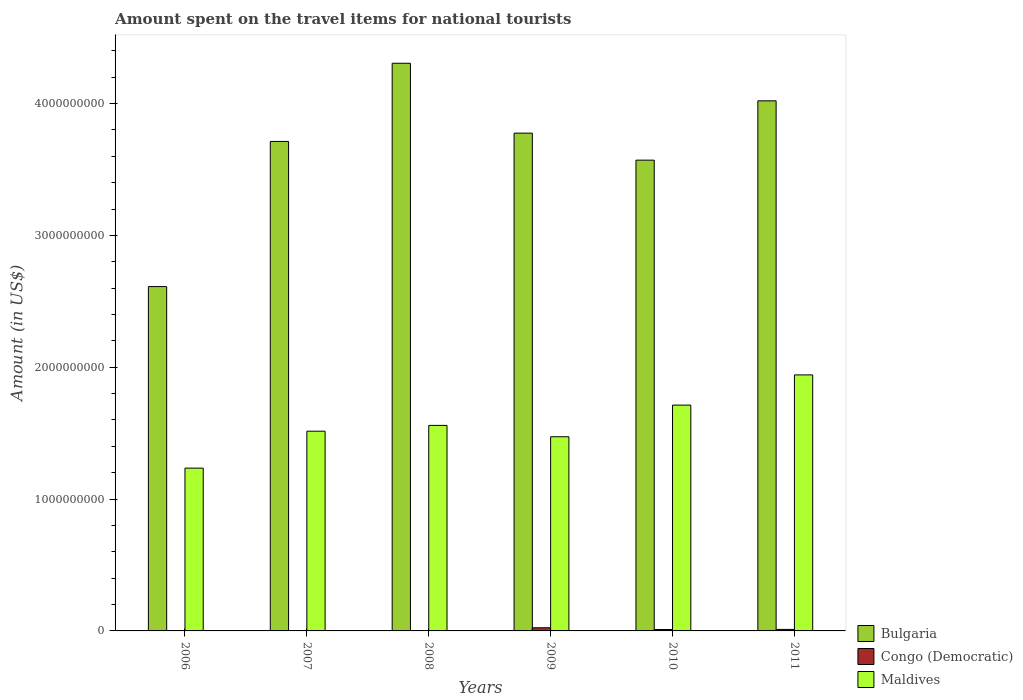How many different coloured bars are there?
Provide a succinct answer. 3. How many groups of bars are there?
Your answer should be very brief. 6. Are the number of bars per tick equal to the number of legend labels?
Make the answer very short. Yes. Are the number of bars on each tick of the X-axis equal?
Provide a succinct answer. Yes. What is the label of the 1st group of bars from the left?
Your response must be concise. 2006. What is the amount spent on the travel items for national tourists in Congo (Democratic) in 2007?
Your answer should be very brief. 7.00e+05. Across all years, what is the maximum amount spent on the travel items for national tourists in Bulgaria?
Provide a short and direct response. 4.31e+09. Across all years, what is the minimum amount spent on the travel items for national tourists in Congo (Democratic)?
Your answer should be very brief. 7.00e+05. In which year was the amount spent on the travel items for national tourists in Bulgaria minimum?
Give a very brief answer. 2006. What is the total amount spent on the travel items for national tourists in Congo (Democratic) in the graph?
Your answer should be very brief. 5.06e+07. What is the difference between the amount spent on the travel items for national tourists in Congo (Democratic) in 2010 and that in 2011?
Your response must be concise. -7.00e+05. What is the difference between the amount spent on the travel items for national tourists in Congo (Democratic) in 2008 and the amount spent on the travel items for national tourists in Bulgaria in 2009?
Offer a very short reply. -3.78e+09. What is the average amount spent on the travel items for national tourists in Maldives per year?
Ensure brevity in your answer.  1.57e+09. In the year 2008, what is the difference between the amount spent on the travel items for national tourists in Congo (Democratic) and amount spent on the travel items for national tourists in Bulgaria?
Your answer should be very brief. -4.31e+09. What is the ratio of the amount spent on the travel items for national tourists in Maldives in 2006 to that in 2007?
Ensure brevity in your answer.  0.82. Is the amount spent on the travel items for national tourists in Bulgaria in 2010 less than that in 2011?
Offer a terse response. Yes. Is the difference between the amount spent on the travel items for national tourists in Congo (Democratic) in 2007 and 2010 greater than the difference between the amount spent on the travel items for national tourists in Bulgaria in 2007 and 2010?
Make the answer very short. No. What is the difference between the highest and the second highest amount spent on the travel items for national tourists in Congo (Democratic)?
Ensure brevity in your answer.  1.26e+07. What is the difference between the highest and the lowest amount spent on the travel items for national tourists in Congo (Democratic)?
Your answer should be compact. 2.33e+07. In how many years, is the amount spent on the travel items for national tourists in Bulgaria greater than the average amount spent on the travel items for national tourists in Bulgaria taken over all years?
Your answer should be very brief. 4. What does the 2nd bar from the left in 2011 represents?
Your response must be concise. Congo (Democratic). What does the 1st bar from the right in 2009 represents?
Offer a very short reply. Maldives. How many years are there in the graph?
Provide a short and direct response. 6. What is the difference between two consecutive major ticks on the Y-axis?
Give a very brief answer. 1.00e+09. Are the values on the major ticks of Y-axis written in scientific E-notation?
Your response must be concise. No. Where does the legend appear in the graph?
Offer a very short reply. Bottom right. How are the legend labels stacked?
Provide a succinct answer. Vertical. What is the title of the graph?
Your response must be concise. Amount spent on the travel items for national tourists. What is the label or title of the X-axis?
Offer a terse response. Years. What is the Amount (in US$) in Bulgaria in 2006?
Provide a short and direct response. 2.61e+09. What is the Amount (in US$) in Congo (Democratic) in 2006?
Your response must be concise. 3.10e+06. What is the Amount (in US$) in Maldives in 2006?
Your answer should be very brief. 1.24e+09. What is the Amount (in US$) in Bulgaria in 2007?
Your response must be concise. 3.71e+09. What is the Amount (in US$) in Maldives in 2007?
Make the answer very short. 1.52e+09. What is the Amount (in US$) in Bulgaria in 2008?
Provide a succinct answer. 4.31e+09. What is the Amount (in US$) of Congo (Democratic) in 2008?
Keep it short and to the point. 7.00e+05. What is the Amount (in US$) in Maldives in 2008?
Provide a short and direct response. 1.56e+09. What is the Amount (in US$) of Bulgaria in 2009?
Give a very brief answer. 3.78e+09. What is the Amount (in US$) in Congo (Democratic) in 2009?
Keep it short and to the point. 2.40e+07. What is the Amount (in US$) of Maldives in 2009?
Provide a short and direct response. 1.47e+09. What is the Amount (in US$) of Bulgaria in 2010?
Your response must be concise. 3.57e+09. What is the Amount (in US$) of Congo (Democratic) in 2010?
Offer a terse response. 1.07e+07. What is the Amount (in US$) of Maldives in 2010?
Your response must be concise. 1.71e+09. What is the Amount (in US$) of Bulgaria in 2011?
Your response must be concise. 4.02e+09. What is the Amount (in US$) of Congo (Democratic) in 2011?
Offer a very short reply. 1.14e+07. What is the Amount (in US$) in Maldives in 2011?
Offer a terse response. 1.94e+09. Across all years, what is the maximum Amount (in US$) in Bulgaria?
Make the answer very short. 4.31e+09. Across all years, what is the maximum Amount (in US$) of Congo (Democratic)?
Offer a terse response. 2.40e+07. Across all years, what is the maximum Amount (in US$) in Maldives?
Offer a very short reply. 1.94e+09. Across all years, what is the minimum Amount (in US$) in Bulgaria?
Provide a succinct answer. 2.61e+09. Across all years, what is the minimum Amount (in US$) in Congo (Democratic)?
Provide a succinct answer. 7.00e+05. Across all years, what is the minimum Amount (in US$) of Maldives?
Your response must be concise. 1.24e+09. What is the total Amount (in US$) in Bulgaria in the graph?
Keep it short and to the point. 2.20e+1. What is the total Amount (in US$) in Congo (Democratic) in the graph?
Keep it short and to the point. 5.06e+07. What is the total Amount (in US$) in Maldives in the graph?
Offer a terse response. 9.44e+09. What is the difference between the Amount (in US$) of Bulgaria in 2006 and that in 2007?
Your response must be concise. -1.10e+09. What is the difference between the Amount (in US$) in Congo (Democratic) in 2006 and that in 2007?
Your answer should be very brief. 2.40e+06. What is the difference between the Amount (in US$) in Maldives in 2006 and that in 2007?
Offer a terse response. -2.80e+08. What is the difference between the Amount (in US$) in Bulgaria in 2006 and that in 2008?
Ensure brevity in your answer.  -1.69e+09. What is the difference between the Amount (in US$) of Congo (Democratic) in 2006 and that in 2008?
Your response must be concise. 2.40e+06. What is the difference between the Amount (in US$) of Maldives in 2006 and that in 2008?
Offer a terse response. -3.24e+08. What is the difference between the Amount (in US$) in Bulgaria in 2006 and that in 2009?
Give a very brief answer. -1.16e+09. What is the difference between the Amount (in US$) of Congo (Democratic) in 2006 and that in 2009?
Your response must be concise. -2.09e+07. What is the difference between the Amount (in US$) of Maldives in 2006 and that in 2009?
Offer a very short reply. -2.38e+08. What is the difference between the Amount (in US$) in Bulgaria in 2006 and that in 2010?
Your answer should be compact. -9.59e+08. What is the difference between the Amount (in US$) of Congo (Democratic) in 2006 and that in 2010?
Provide a short and direct response. -7.60e+06. What is the difference between the Amount (in US$) of Maldives in 2006 and that in 2010?
Your response must be concise. -4.78e+08. What is the difference between the Amount (in US$) of Bulgaria in 2006 and that in 2011?
Keep it short and to the point. -1.41e+09. What is the difference between the Amount (in US$) in Congo (Democratic) in 2006 and that in 2011?
Offer a terse response. -8.30e+06. What is the difference between the Amount (in US$) in Maldives in 2006 and that in 2011?
Your answer should be compact. -7.07e+08. What is the difference between the Amount (in US$) of Bulgaria in 2007 and that in 2008?
Your answer should be very brief. -5.93e+08. What is the difference between the Amount (in US$) of Maldives in 2007 and that in 2008?
Give a very brief answer. -4.40e+07. What is the difference between the Amount (in US$) in Bulgaria in 2007 and that in 2009?
Your answer should be very brief. -6.30e+07. What is the difference between the Amount (in US$) of Congo (Democratic) in 2007 and that in 2009?
Keep it short and to the point. -2.33e+07. What is the difference between the Amount (in US$) in Maldives in 2007 and that in 2009?
Offer a terse response. 4.20e+07. What is the difference between the Amount (in US$) in Bulgaria in 2007 and that in 2010?
Provide a succinct answer. 1.42e+08. What is the difference between the Amount (in US$) of Congo (Democratic) in 2007 and that in 2010?
Keep it short and to the point. -1.00e+07. What is the difference between the Amount (in US$) of Maldives in 2007 and that in 2010?
Your answer should be compact. -1.98e+08. What is the difference between the Amount (in US$) of Bulgaria in 2007 and that in 2011?
Offer a terse response. -3.08e+08. What is the difference between the Amount (in US$) of Congo (Democratic) in 2007 and that in 2011?
Your response must be concise. -1.07e+07. What is the difference between the Amount (in US$) of Maldives in 2007 and that in 2011?
Provide a short and direct response. -4.27e+08. What is the difference between the Amount (in US$) in Bulgaria in 2008 and that in 2009?
Your answer should be very brief. 5.30e+08. What is the difference between the Amount (in US$) in Congo (Democratic) in 2008 and that in 2009?
Ensure brevity in your answer.  -2.33e+07. What is the difference between the Amount (in US$) of Maldives in 2008 and that in 2009?
Give a very brief answer. 8.60e+07. What is the difference between the Amount (in US$) of Bulgaria in 2008 and that in 2010?
Keep it short and to the point. 7.35e+08. What is the difference between the Amount (in US$) in Congo (Democratic) in 2008 and that in 2010?
Offer a terse response. -1.00e+07. What is the difference between the Amount (in US$) of Maldives in 2008 and that in 2010?
Give a very brief answer. -1.54e+08. What is the difference between the Amount (in US$) in Bulgaria in 2008 and that in 2011?
Ensure brevity in your answer.  2.85e+08. What is the difference between the Amount (in US$) of Congo (Democratic) in 2008 and that in 2011?
Give a very brief answer. -1.07e+07. What is the difference between the Amount (in US$) in Maldives in 2008 and that in 2011?
Provide a succinct answer. -3.83e+08. What is the difference between the Amount (in US$) of Bulgaria in 2009 and that in 2010?
Ensure brevity in your answer.  2.05e+08. What is the difference between the Amount (in US$) in Congo (Democratic) in 2009 and that in 2010?
Provide a short and direct response. 1.33e+07. What is the difference between the Amount (in US$) of Maldives in 2009 and that in 2010?
Offer a very short reply. -2.40e+08. What is the difference between the Amount (in US$) in Bulgaria in 2009 and that in 2011?
Offer a very short reply. -2.45e+08. What is the difference between the Amount (in US$) of Congo (Democratic) in 2009 and that in 2011?
Provide a short and direct response. 1.26e+07. What is the difference between the Amount (in US$) in Maldives in 2009 and that in 2011?
Give a very brief answer. -4.69e+08. What is the difference between the Amount (in US$) of Bulgaria in 2010 and that in 2011?
Keep it short and to the point. -4.50e+08. What is the difference between the Amount (in US$) of Congo (Democratic) in 2010 and that in 2011?
Your answer should be very brief. -7.00e+05. What is the difference between the Amount (in US$) in Maldives in 2010 and that in 2011?
Provide a short and direct response. -2.29e+08. What is the difference between the Amount (in US$) of Bulgaria in 2006 and the Amount (in US$) of Congo (Democratic) in 2007?
Your response must be concise. 2.61e+09. What is the difference between the Amount (in US$) of Bulgaria in 2006 and the Amount (in US$) of Maldives in 2007?
Offer a very short reply. 1.10e+09. What is the difference between the Amount (in US$) in Congo (Democratic) in 2006 and the Amount (in US$) in Maldives in 2007?
Make the answer very short. -1.51e+09. What is the difference between the Amount (in US$) of Bulgaria in 2006 and the Amount (in US$) of Congo (Democratic) in 2008?
Ensure brevity in your answer.  2.61e+09. What is the difference between the Amount (in US$) of Bulgaria in 2006 and the Amount (in US$) of Maldives in 2008?
Ensure brevity in your answer.  1.05e+09. What is the difference between the Amount (in US$) of Congo (Democratic) in 2006 and the Amount (in US$) of Maldives in 2008?
Keep it short and to the point. -1.56e+09. What is the difference between the Amount (in US$) of Bulgaria in 2006 and the Amount (in US$) of Congo (Democratic) in 2009?
Offer a terse response. 2.59e+09. What is the difference between the Amount (in US$) in Bulgaria in 2006 and the Amount (in US$) in Maldives in 2009?
Your answer should be compact. 1.14e+09. What is the difference between the Amount (in US$) of Congo (Democratic) in 2006 and the Amount (in US$) of Maldives in 2009?
Offer a very short reply. -1.47e+09. What is the difference between the Amount (in US$) of Bulgaria in 2006 and the Amount (in US$) of Congo (Democratic) in 2010?
Your answer should be compact. 2.60e+09. What is the difference between the Amount (in US$) of Bulgaria in 2006 and the Amount (in US$) of Maldives in 2010?
Your answer should be compact. 8.99e+08. What is the difference between the Amount (in US$) of Congo (Democratic) in 2006 and the Amount (in US$) of Maldives in 2010?
Give a very brief answer. -1.71e+09. What is the difference between the Amount (in US$) in Bulgaria in 2006 and the Amount (in US$) in Congo (Democratic) in 2011?
Give a very brief answer. 2.60e+09. What is the difference between the Amount (in US$) in Bulgaria in 2006 and the Amount (in US$) in Maldives in 2011?
Your answer should be compact. 6.70e+08. What is the difference between the Amount (in US$) in Congo (Democratic) in 2006 and the Amount (in US$) in Maldives in 2011?
Provide a short and direct response. -1.94e+09. What is the difference between the Amount (in US$) in Bulgaria in 2007 and the Amount (in US$) in Congo (Democratic) in 2008?
Ensure brevity in your answer.  3.71e+09. What is the difference between the Amount (in US$) of Bulgaria in 2007 and the Amount (in US$) of Maldives in 2008?
Your response must be concise. 2.15e+09. What is the difference between the Amount (in US$) in Congo (Democratic) in 2007 and the Amount (in US$) in Maldives in 2008?
Give a very brief answer. -1.56e+09. What is the difference between the Amount (in US$) in Bulgaria in 2007 and the Amount (in US$) in Congo (Democratic) in 2009?
Your response must be concise. 3.69e+09. What is the difference between the Amount (in US$) of Bulgaria in 2007 and the Amount (in US$) of Maldives in 2009?
Keep it short and to the point. 2.24e+09. What is the difference between the Amount (in US$) in Congo (Democratic) in 2007 and the Amount (in US$) in Maldives in 2009?
Your response must be concise. -1.47e+09. What is the difference between the Amount (in US$) of Bulgaria in 2007 and the Amount (in US$) of Congo (Democratic) in 2010?
Offer a very short reply. 3.70e+09. What is the difference between the Amount (in US$) in Congo (Democratic) in 2007 and the Amount (in US$) in Maldives in 2010?
Make the answer very short. -1.71e+09. What is the difference between the Amount (in US$) in Bulgaria in 2007 and the Amount (in US$) in Congo (Democratic) in 2011?
Keep it short and to the point. 3.70e+09. What is the difference between the Amount (in US$) in Bulgaria in 2007 and the Amount (in US$) in Maldives in 2011?
Provide a succinct answer. 1.77e+09. What is the difference between the Amount (in US$) in Congo (Democratic) in 2007 and the Amount (in US$) in Maldives in 2011?
Your answer should be very brief. -1.94e+09. What is the difference between the Amount (in US$) in Bulgaria in 2008 and the Amount (in US$) in Congo (Democratic) in 2009?
Offer a terse response. 4.28e+09. What is the difference between the Amount (in US$) in Bulgaria in 2008 and the Amount (in US$) in Maldives in 2009?
Make the answer very short. 2.83e+09. What is the difference between the Amount (in US$) of Congo (Democratic) in 2008 and the Amount (in US$) of Maldives in 2009?
Keep it short and to the point. -1.47e+09. What is the difference between the Amount (in US$) of Bulgaria in 2008 and the Amount (in US$) of Congo (Democratic) in 2010?
Give a very brief answer. 4.30e+09. What is the difference between the Amount (in US$) in Bulgaria in 2008 and the Amount (in US$) in Maldives in 2010?
Keep it short and to the point. 2.59e+09. What is the difference between the Amount (in US$) of Congo (Democratic) in 2008 and the Amount (in US$) of Maldives in 2010?
Your response must be concise. -1.71e+09. What is the difference between the Amount (in US$) of Bulgaria in 2008 and the Amount (in US$) of Congo (Democratic) in 2011?
Keep it short and to the point. 4.29e+09. What is the difference between the Amount (in US$) in Bulgaria in 2008 and the Amount (in US$) in Maldives in 2011?
Ensure brevity in your answer.  2.36e+09. What is the difference between the Amount (in US$) of Congo (Democratic) in 2008 and the Amount (in US$) of Maldives in 2011?
Your answer should be very brief. -1.94e+09. What is the difference between the Amount (in US$) of Bulgaria in 2009 and the Amount (in US$) of Congo (Democratic) in 2010?
Provide a succinct answer. 3.77e+09. What is the difference between the Amount (in US$) of Bulgaria in 2009 and the Amount (in US$) of Maldives in 2010?
Provide a short and direct response. 2.06e+09. What is the difference between the Amount (in US$) of Congo (Democratic) in 2009 and the Amount (in US$) of Maldives in 2010?
Provide a short and direct response. -1.69e+09. What is the difference between the Amount (in US$) in Bulgaria in 2009 and the Amount (in US$) in Congo (Democratic) in 2011?
Ensure brevity in your answer.  3.76e+09. What is the difference between the Amount (in US$) of Bulgaria in 2009 and the Amount (in US$) of Maldives in 2011?
Keep it short and to the point. 1.83e+09. What is the difference between the Amount (in US$) in Congo (Democratic) in 2009 and the Amount (in US$) in Maldives in 2011?
Ensure brevity in your answer.  -1.92e+09. What is the difference between the Amount (in US$) of Bulgaria in 2010 and the Amount (in US$) of Congo (Democratic) in 2011?
Your answer should be very brief. 3.56e+09. What is the difference between the Amount (in US$) in Bulgaria in 2010 and the Amount (in US$) in Maldives in 2011?
Keep it short and to the point. 1.63e+09. What is the difference between the Amount (in US$) of Congo (Democratic) in 2010 and the Amount (in US$) of Maldives in 2011?
Keep it short and to the point. -1.93e+09. What is the average Amount (in US$) of Bulgaria per year?
Make the answer very short. 3.67e+09. What is the average Amount (in US$) in Congo (Democratic) per year?
Offer a terse response. 8.43e+06. What is the average Amount (in US$) of Maldives per year?
Your response must be concise. 1.57e+09. In the year 2006, what is the difference between the Amount (in US$) of Bulgaria and Amount (in US$) of Congo (Democratic)?
Keep it short and to the point. 2.61e+09. In the year 2006, what is the difference between the Amount (in US$) of Bulgaria and Amount (in US$) of Maldives?
Offer a very short reply. 1.38e+09. In the year 2006, what is the difference between the Amount (in US$) in Congo (Democratic) and Amount (in US$) in Maldives?
Make the answer very short. -1.23e+09. In the year 2007, what is the difference between the Amount (in US$) in Bulgaria and Amount (in US$) in Congo (Democratic)?
Provide a succinct answer. 3.71e+09. In the year 2007, what is the difference between the Amount (in US$) in Bulgaria and Amount (in US$) in Maldives?
Offer a terse response. 2.20e+09. In the year 2007, what is the difference between the Amount (in US$) in Congo (Democratic) and Amount (in US$) in Maldives?
Provide a succinct answer. -1.51e+09. In the year 2008, what is the difference between the Amount (in US$) in Bulgaria and Amount (in US$) in Congo (Democratic)?
Provide a succinct answer. 4.31e+09. In the year 2008, what is the difference between the Amount (in US$) in Bulgaria and Amount (in US$) in Maldives?
Your answer should be very brief. 2.75e+09. In the year 2008, what is the difference between the Amount (in US$) of Congo (Democratic) and Amount (in US$) of Maldives?
Your answer should be compact. -1.56e+09. In the year 2009, what is the difference between the Amount (in US$) of Bulgaria and Amount (in US$) of Congo (Democratic)?
Keep it short and to the point. 3.75e+09. In the year 2009, what is the difference between the Amount (in US$) in Bulgaria and Amount (in US$) in Maldives?
Offer a very short reply. 2.30e+09. In the year 2009, what is the difference between the Amount (in US$) in Congo (Democratic) and Amount (in US$) in Maldives?
Your answer should be very brief. -1.45e+09. In the year 2010, what is the difference between the Amount (in US$) in Bulgaria and Amount (in US$) in Congo (Democratic)?
Provide a succinct answer. 3.56e+09. In the year 2010, what is the difference between the Amount (in US$) in Bulgaria and Amount (in US$) in Maldives?
Offer a very short reply. 1.86e+09. In the year 2010, what is the difference between the Amount (in US$) of Congo (Democratic) and Amount (in US$) of Maldives?
Provide a succinct answer. -1.70e+09. In the year 2011, what is the difference between the Amount (in US$) in Bulgaria and Amount (in US$) in Congo (Democratic)?
Your answer should be compact. 4.01e+09. In the year 2011, what is the difference between the Amount (in US$) in Bulgaria and Amount (in US$) in Maldives?
Ensure brevity in your answer.  2.08e+09. In the year 2011, what is the difference between the Amount (in US$) in Congo (Democratic) and Amount (in US$) in Maldives?
Provide a succinct answer. -1.93e+09. What is the ratio of the Amount (in US$) of Bulgaria in 2006 to that in 2007?
Provide a succinct answer. 0.7. What is the ratio of the Amount (in US$) of Congo (Democratic) in 2006 to that in 2007?
Offer a very short reply. 4.43. What is the ratio of the Amount (in US$) of Maldives in 2006 to that in 2007?
Offer a terse response. 0.82. What is the ratio of the Amount (in US$) of Bulgaria in 2006 to that in 2008?
Keep it short and to the point. 0.61. What is the ratio of the Amount (in US$) of Congo (Democratic) in 2006 to that in 2008?
Make the answer very short. 4.43. What is the ratio of the Amount (in US$) in Maldives in 2006 to that in 2008?
Your response must be concise. 0.79. What is the ratio of the Amount (in US$) of Bulgaria in 2006 to that in 2009?
Ensure brevity in your answer.  0.69. What is the ratio of the Amount (in US$) in Congo (Democratic) in 2006 to that in 2009?
Your answer should be very brief. 0.13. What is the ratio of the Amount (in US$) of Maldives in 2006 to that in 2009?
Your answer should be compact. 0.84. What is the ratio of the Amount (in US$) of Bulgaria in 2006 to that in 2010?
Offer a terse response. 0.73. What is the ratio of the Amount (in US$) of Congo (Democratic) in 2006 to that in 2010?
Provide a succinct answer. 0.29. What is the ratio of the Amount (in US$) in Maldives in 2006 to that in 2010?
Keep it short and to the point. 0.72. What is the ratio of the Amount (in US$) in Bulgaria in 2006 to that in 2011?
Provide a succinct answer. 0.65. What is the ratio of the Amount (in US$) in Congo (Democratic) in 2006 to that in 2011?
Keep it short and to the point. 0.27. What is the ratio of the Amount (in US$) of Maldives in 2006 to that in 2011?
Offer a very short reply. 0.64. What is the ratio of the Amount (in US$) in Bulgaria in 2007 to that in 2008?
Your answer should be compact. 0.86. What is the ratio of the Amount (in US$) of Congo (Democratic) in 2007 to that in 2008?
Make the answer very short. 1. What is the ratio of the Amount (in US$) of Maldives in 2007 to that in 2008?
Offer a very short reply. 0.97. What is the ratio of the Amount (in US$) of Bulgaria in 2007 to that in 2009?
Your answer should be very brief. 0.98. What is the ratio of the Amount (in US$) in Congo (Democratic) in 2007 to that in 2009?
Provide a short and direct response. 0.03. What is the ratio of the Amount (in US$) of Maldives in 2007 to that in 2009?
Make the answer very short. 1.03. What is the ratio of the Amount (in US$) of Bulgaria in 2007 to that in 2010?
Your answer should be compact. 1.04. What is the ratio of the Amount (in US$) in Congo (Democratic) in 2007 to that in 2010?
Provide a succinct answer. 0.07. What is the ratio of the Amount (in US$) in Maldives in 2007 to that in 2010?
Keep it short and to the point. 0.88. What is the ratio of the Amount (in US$) of Bulgaria in 2007 to that in 2011?
Your answer should be very brief. 0.92. What is the ratio of the Amount (in US$) of Congo (Democratic) in 2007 to that in 2011?
Ensure brevity in your answer.  0.06. What is the ratio of the Amount (in US$) in Maldives in 2007 to that in 2011?
Give a very brief answer. 0.78. What is the ratio of the Amount (in US$) of Bulgaria in 2008 to that in 2009?
Offer a terse response. 1.14. What is the ratio of the Amount (in US$) in Congo (Democratic) in 2008 to that in 2009?
Your answer should be very brief. 0.03. What is the ratio of the Amount (in US$) in Maldives in 2008 to that in 2009?
Your answer should be compact. 1.06. What is the ratio of the Amount (in US$) in Bulgaria in 2008 to that in 2010?
Offer a very short reply. 1.21. What is the ratio of the Amount (in US$) in Congo (Democratic) in 2008 to that in 2010?
Ensure brevity in your answer.  0.07. What is the ratio of the Amount (in US$) in Maldives in 2008 to that in 2010?
Provide a short and direct response. 0.91. What is the ratio of the Amount (in US$) in Bulgaria in 2008 to that in 2011?
Offer a terse response. 1.07. What is the ratio of the Amount (in US$) of Congo (Democratic) in 2008 to that in 2011?
Ensure brevity in your answer.  0.06. What is the ratio of the Amount (in US$) of Maldives in 2008 to that in 2011?
Provide a succinct answer. 0.8. What is the ratio of the Amount (in US$) in Bulgaria in 2009 to that in 2010?
Offer a terse response. 1.06. What is the ratio of the Amount (in US$) in Congo (Democratic) in 2009 to that in 2010?
Provide a short and direct response. 2.24. What is the ratio of the Amount (in US$) of Maldives in 2009 to that in 2010?
Ensure brevity in your answer.  0.86. What is the ratio of the Amount (in US$) of Bulgaria in 2009 to that in 2011?
Your answer should be compact. 0.94. What is the ratio of the Amount (in US$) in Congo (Democratic) in 2009 to that in 2011?
Your answer should be very brief. 2.11. What is the ratio of the Amount (in US$) in Maldives in 2009 to that in 2011?
Offer a terse response. 0.76. What is the ratio of the Amount (in US$) in Bulgaria in 2010 to that in 2011?
Provide a succinct answer. 0.89. What is the ratio of the Amount (in US$) in Congo (Democratic) in 2010 to that in 2011?
Provide a short and direct response. 0.94. What is the ratio of the Amount (in US$) of Maldives in 2010 to that in 2011?
Give a very brief answer. 0.88. What is the difference between the highest and the second highest Amount (in US$) in Bulgaria?
Your response must be concise. 2.85e+08. What is the difference between the highest and the second highest Amount (in US$) in Congo (Democratic)?
Your response must be concise. 1.26e+07. What is the difference between the highest and the second highest Amount (in US$) of Maldives?
Offer a terse response. 2.29e+08. What is the difference between the highest and the lowest Amount (in US$) of Bulgaria?
Offer a very short reply. 1.69e+09. What is the difference between the highest and the lowest Amount (in US$) of Congo (Democratic)?
Provide a succinct answer. 2.33e+07. What is the difference between the highest and the lowest Amount (in US$) in Maldives?
Make the answer very short. 7.07e+08. 